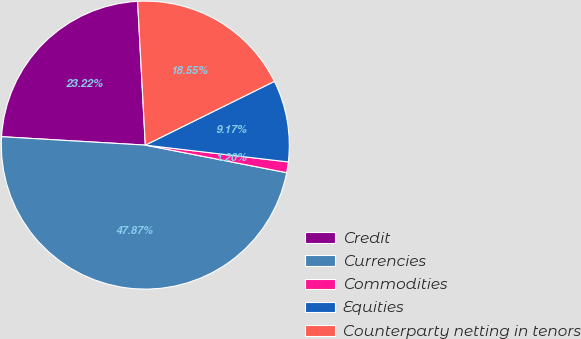Convert chart to OTSL. <chart><loc_0><loc_0><loc_500><loc_500><pie_chart><fcel>Credit<fcel>Currencies<fcel>Commodities<fcel>Equities<fcel>Counterparty netting in tenors<nl><fcel>23.22%<fcel>47.87%<fcel>1.2%<fcel>9.17%<fcel>18.55%<nl></chart> 